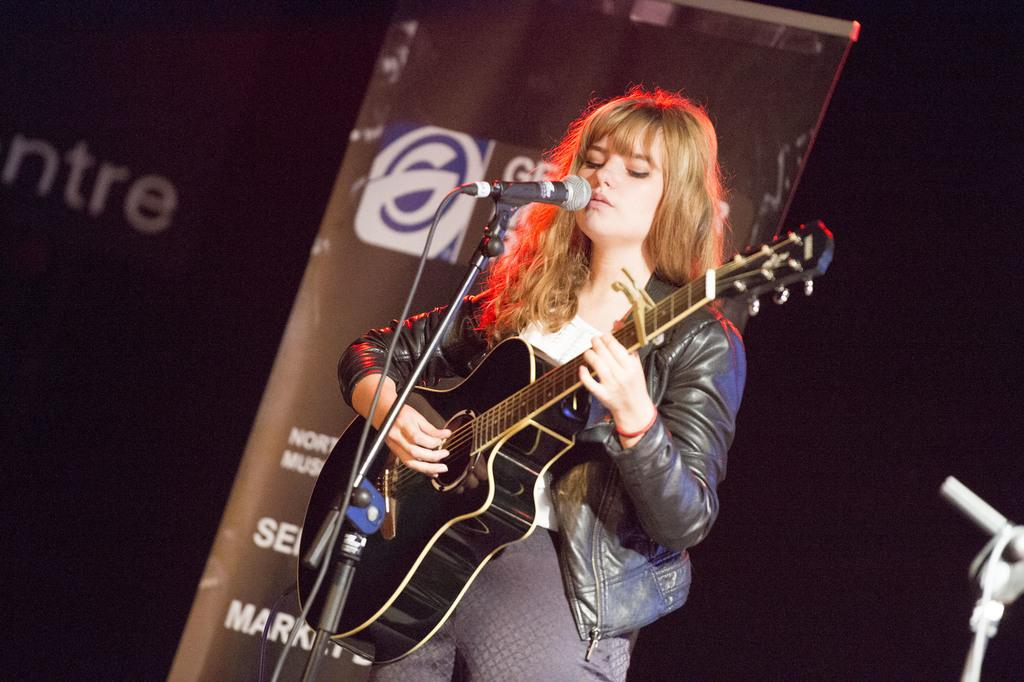Who is the main subject in the image? There is a woman in the image. What is the woman holding in her hands? The woman is holding a guitar and a microphone. What can be seen in the background of the image? There are banners in the background of the image. How many balls are visible in the image? There are no balls present in the image. What type of light source is illuminating the woman in the image? The image does not provide information about the light source; it only shows the woman, her guitar, the microphone, and the banners in the background. 